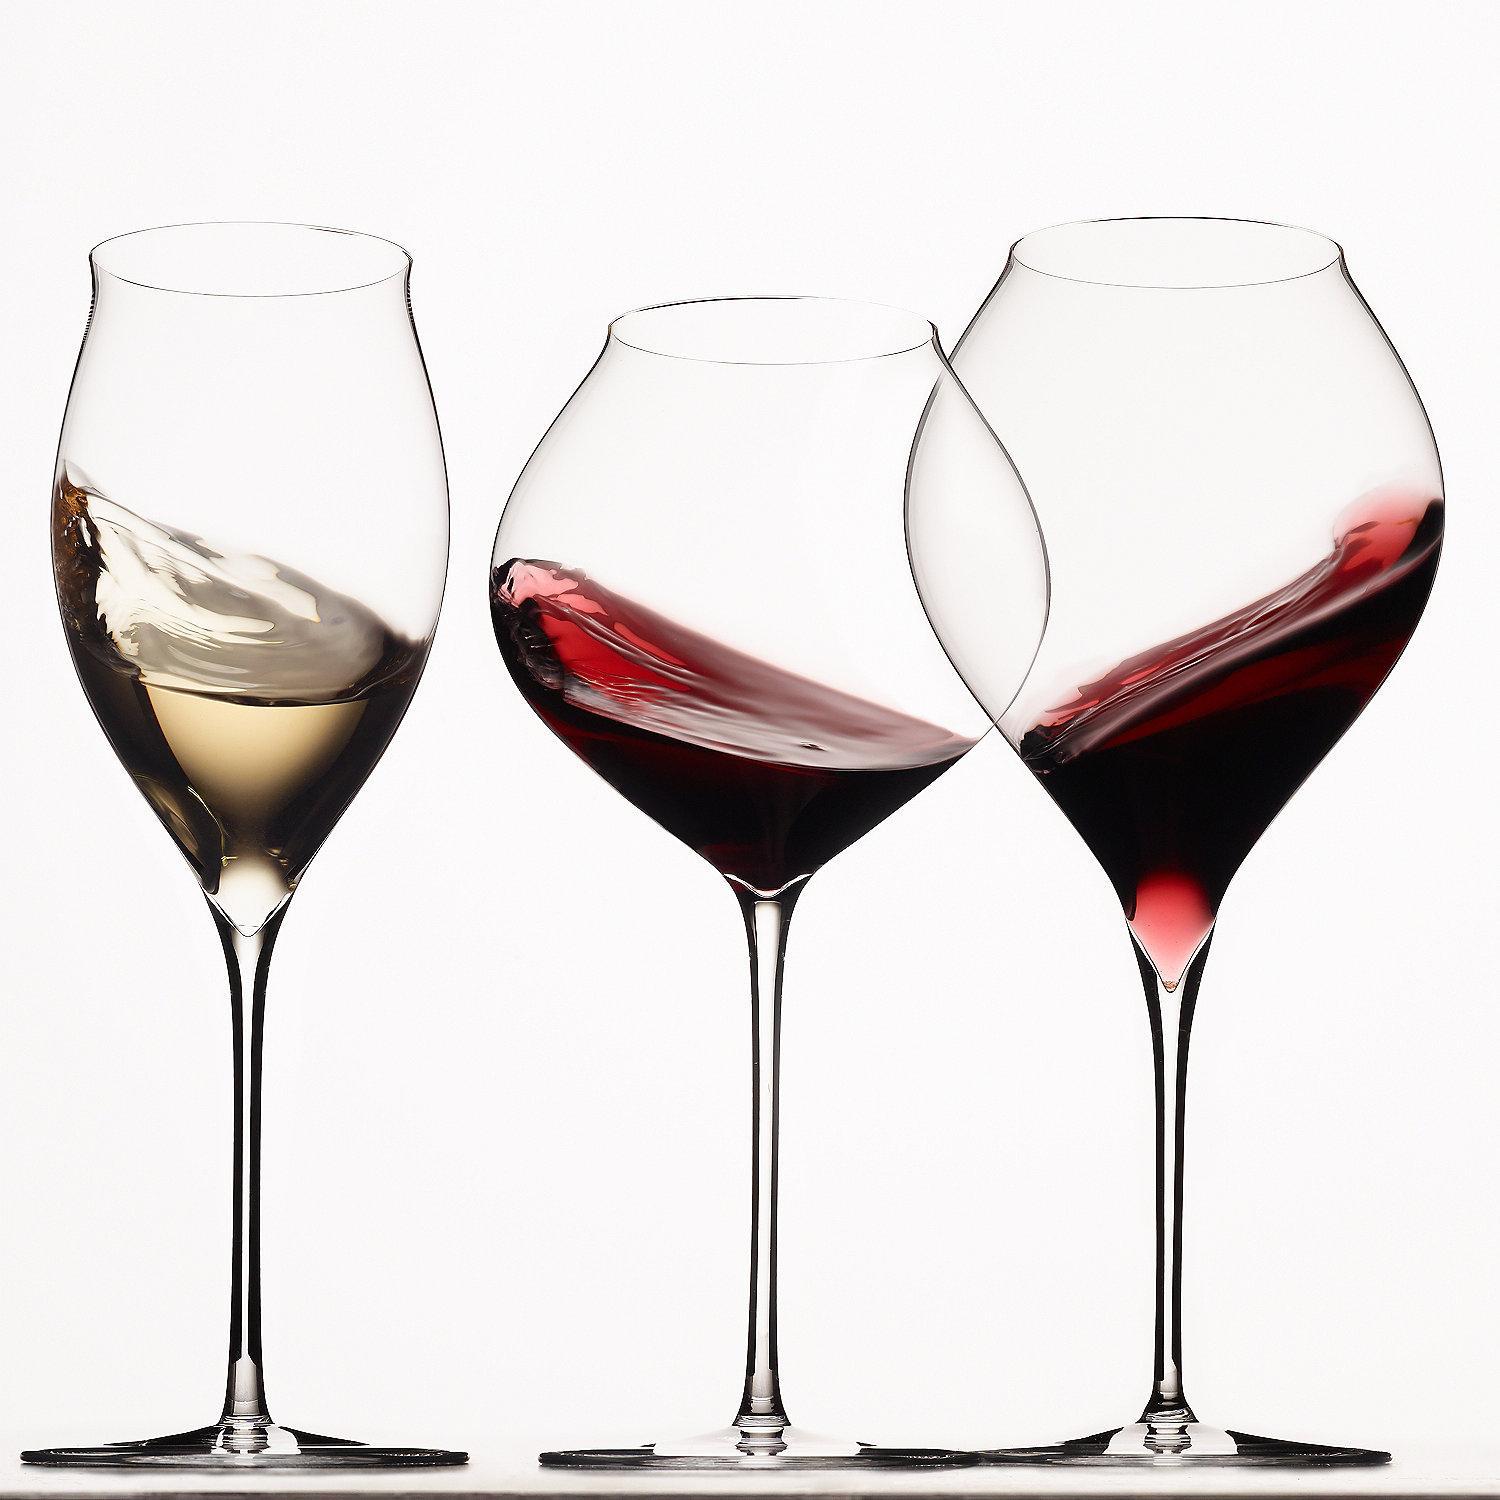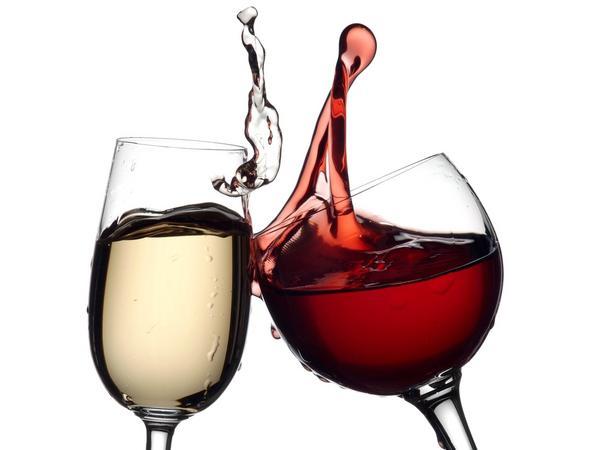The first image is the image on the left, the second image is the image on the right. Considering the images on both sides, is "The neck of the bottle is near a glass." valid? Answer yes or no. No. 